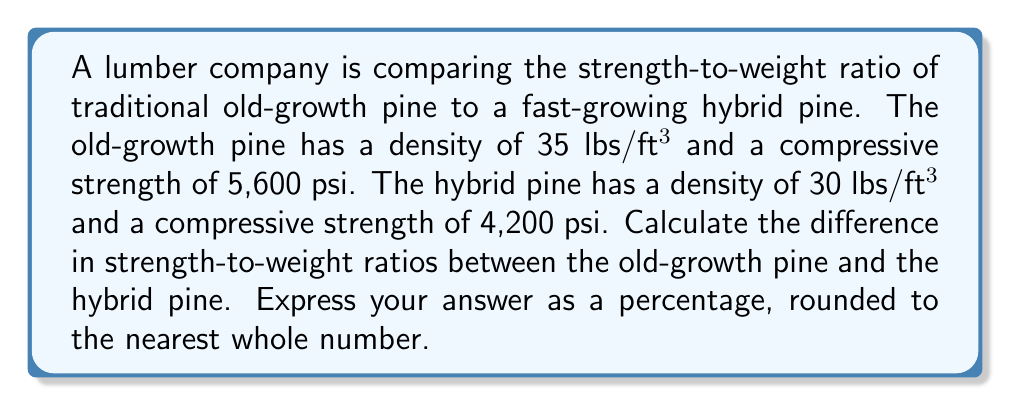Could you help me with this problem? 1. Calculate the strength-to-weight ratio for old-growth pine:
   $$ \text{Ratio}_{\text{old}} = \frac{\text{Compressive Strength}}{\text{Density}} = \frac{5,600 \text{ psi}}{35 \text{ lbs/ft³}} = 160 \text{ psi/(lbs/ft³)} $$

2. Calculate the strength-to-weight ratio for hybrid pine:
   $$ \text{Ratio}_{\text{hybrid}} = \frac{\text{Compressive Strength}}{\text{Density}} = \frac{4,200 \text{ psi}}{30 \text{ lbs/ft³}} = 140 \text{ psi/(lbs/ft³)} $$

3. Calculate the difference in ratios:
   $$ \text{Difference} = \text{Ratio}_{\text{old}} - \text{Ratio}_{\text{hybrid}} = 160 - 140 = 20 \text{ psi/(lbs/ft³)} $$

4. Express the difference as a percentage of the hybrid pine's ratio:
   $$ \text{Percentage Difference} = \frac{\text{Difference}}{\text{Ratio}_{\text{hybrid}}} \times 100\% $$
   $$ = \frac{20}{140} \times 100\% = 14.29\% $$

5. Round to the nearest whole number:
   14.29% rounds to 14%

Therefore, the old-growth pine has a strength-to-weight ratio that is 14% higher than the hybrid pine.
Answer: 14% 